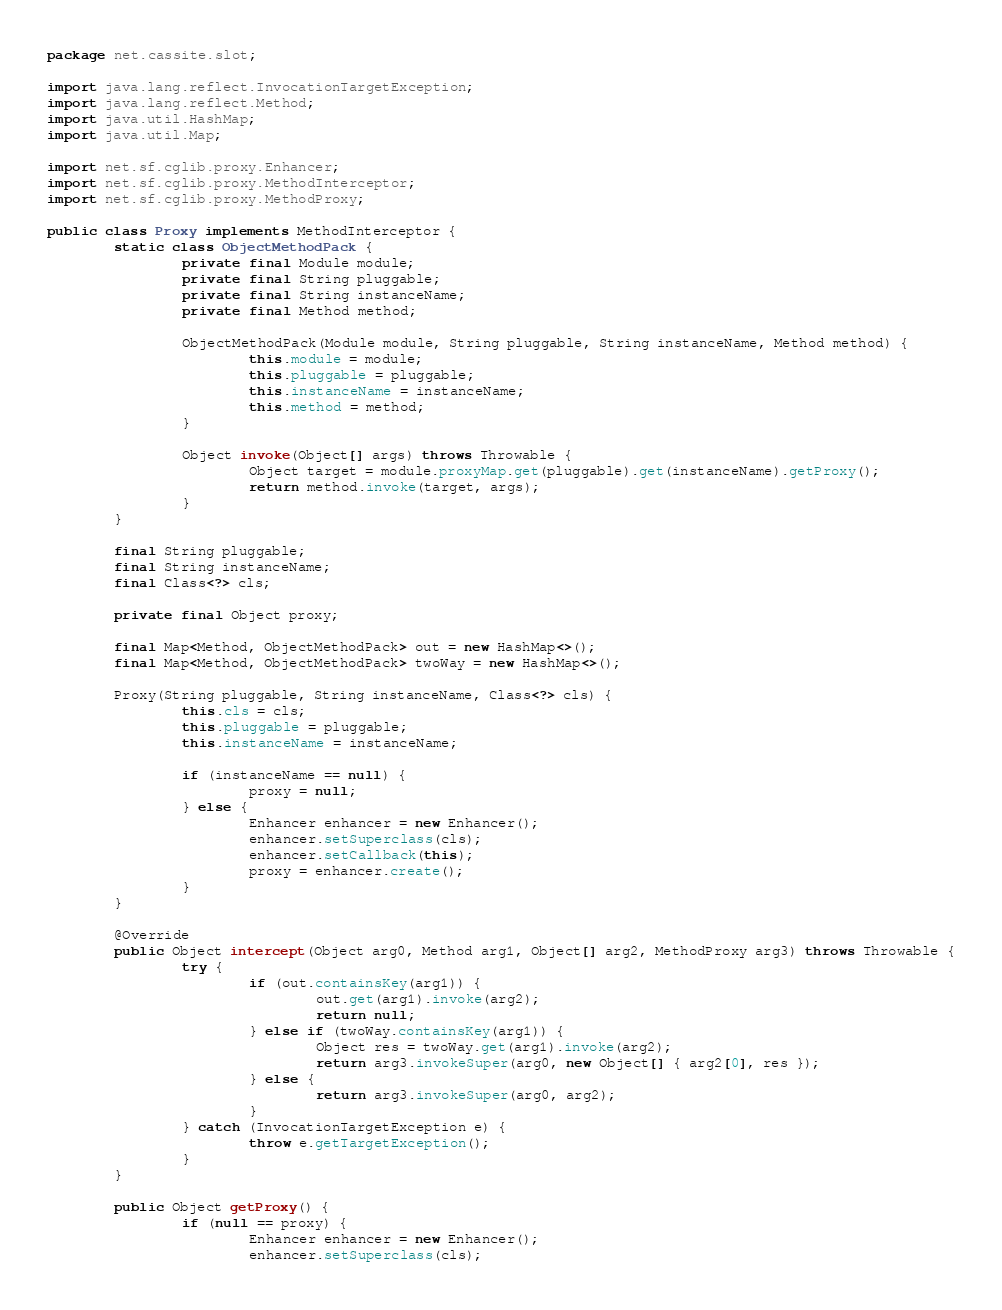<code> <loc_0><loc_0><loc_500><loc_500><_Java_>package net.cassite.slot;

import java.lang.reflect.InvocationTargetException;
import java.lang.reflect.Method;
import java.util.HashMap;
import java.util.Map;

import net.sf.cglib.proxy.Enhancer;
import net.sf.cglib.proxy.MethodInterceptor;
import net.sf.cglib.proxy.MethodProxy;

public class Proxy implements MethodInterceptor {
        static class ObjectMethodPack {
                private final Module module;
                private final String pluggable;
                private final String instanceName;
                private final Method method;

                ObjectMethodPack(Module module, String pluggable, String instanceName, Method method) {
                        this.module = module;
                        this.pluggable = pluggable;
                        this.instanceName = instanceName;
                        this.method = method;
                }

                Object invoke(Object[] args) throws Throwable {
                        Object target = module.proxyMap.get(pluggable).get(instanceName).getProxy();
                        return method.invoke(target, args);
                }
        }

        final String pluggable;
        final String instanceName;
        final Class<?> cls;

        private final Object proxy;

        final Map<Method, ObjectMethodPack> out = new HashMap<>();
        final Map<Method, ObjectMethodPack> twoWay = new HashMap<>();

        Proxy(String pluggable, String instanceName, Class<?> cls) {
                this.cls = cls;
                this.pluggable = pluggable;
                this.instanceName = instanceName;

                if (instanceName == null) {
                        proxy = null;
                } else {
                        Enhancer enhancer = new Enhancer();
                        enhancer.setSuperclass(cls);
                        enhancer.setCallback(this);
                        proxy = enhancer.create();
                }
        }

        @Override
        public Object intercept(Object arg0, Method arg1, Object[] arg2, MethodProxy arg3) throws Throwable {
                try {
                        if (out.containsKey(arg1)) {
                                out.get(arg1).invoke(arg2);
                                return null;
                        } else if (twoWay.containsKey(arg1)) {
                                Object res = twoWay.get(arg1).invoke(arg2);
                                return arg3.invokeSuper(arg0, new Object[] { arg2[0], res });
                        } else {
                                return arg3.invokeSuper(arg0, arg2);
                        }
                } catch (InvocationTargetException e) {
                        throw e.getTargetException();
                }
        }

        public Object getProxy() {
                if (null == proxy) {
                        Enhancer enhancer = new Enhancer();
                        enhancer.setSuperclass(cls);</code> 